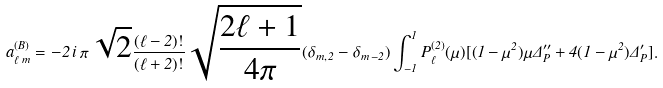<formula> <loc_0><loc_0><loc_500><loc_500>a _ { \ell \, m } ^ { ( B ) } = - 2 \, i \, \pi \, \sqrt { 2 } \frac { ( \ell - 2 ) ! } { ( \ell + 2 ) ! } \sqrt { \frac { 2 \ell + 1 } { 4 \pi } } ( \delta _ { m , \, 2 } - \delta _ { m \, - 2 } ) \int _ { - 1 } ^ { 1 } P _ { \ell } ^ { ( 2 ) } ( \mu ) [ ( 1 - \mu ^ { 2 } ) \mu \Delta _ { P } ^ { \prime \prime } + 4 ( 1 - \mu ^ { 2 } ) \Delta _ { P } ^ { \prime } ] .</formula> 